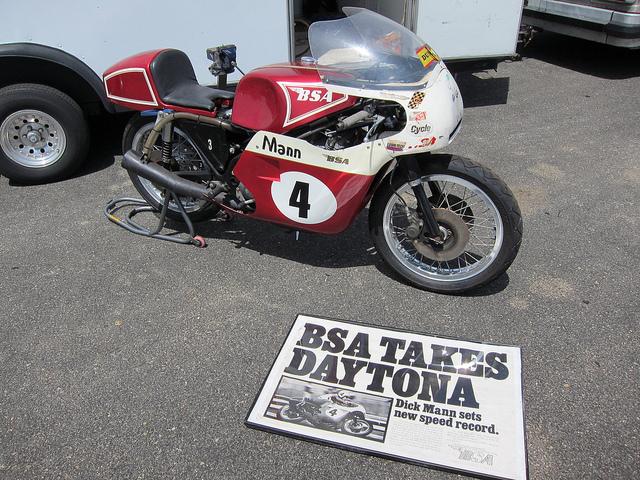Where was the race at?
Be succinct. Daytona. What is the license plate number of the motorcycle?
Be succinct. 4. What color is the motorcycle pictured in the newspaper?
Be succinct. Red and white. Is there a man fixing the bike?
Write a very short answer. No. 